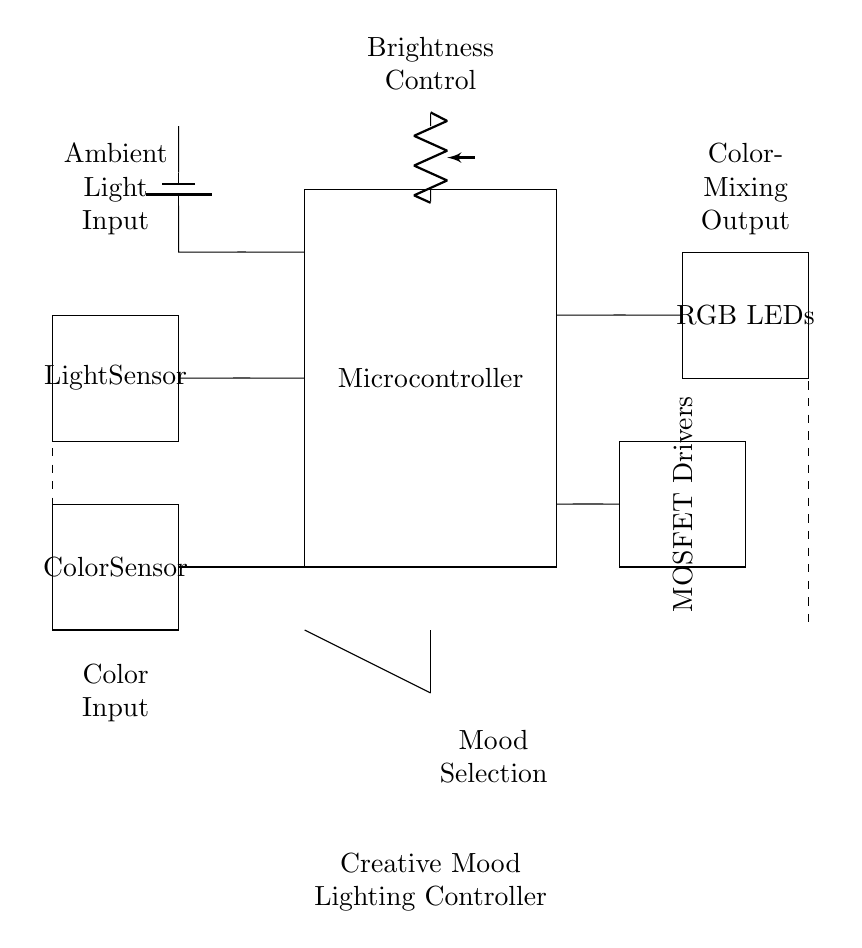What type of sensors are used in this circuit? The circuit diagram includes two types of sensors: an ambient light sensor and a color sensor. These sensors are shown as rectangles labeled "Light Sensor" and "Color Sensor."
Answer: Ambient light sensor and color sensor How many RGB LEDs are present in this circuit diagram? The circuit diagram contains one block labeled "RGB LEDs," which suggests the presence of multiple LEDs; however, the exact count of RGB LEDs is not specified in the diagram itself, leading to an assumption of multiple LEDs for color mixing.
Answer: Multiple What is the purpose of the potentiometer in the circuit? The potentiometer is labeled "Brightness Control" in the circuit diagram, indicating it is used to adjust the brightness of the connected LEDs based on user input.
Answer: Brightness adjustment Which component drives the RGB LEDs? The diagram shows a block labeled "MOSFET Drivers," which indicates that these components are responsible for controlling the power delivered to the RGB LEDs, allowing for dynamic color mixing and brightness control.
Answer: MOSFET Drivers What happens when the mood selection switch is activated? The mood selection switch (SPDT) in the circuit directs the signal (indicated by the line) that can select different mood settings based on the input received, which likely alters how the lighting is presented through the RGB LEDs.
Answer: Alters mood settings How does light input affect the operation of the controller? The ambient light sensor measures the light input, which is crucial for the controller to adjust the brightness of the RGB LEDs automatically, allowing for an interactive and responsive mood lighting setup that reacts to the environment's lighting conditions.
Answer: Adjusts brightness automatically 